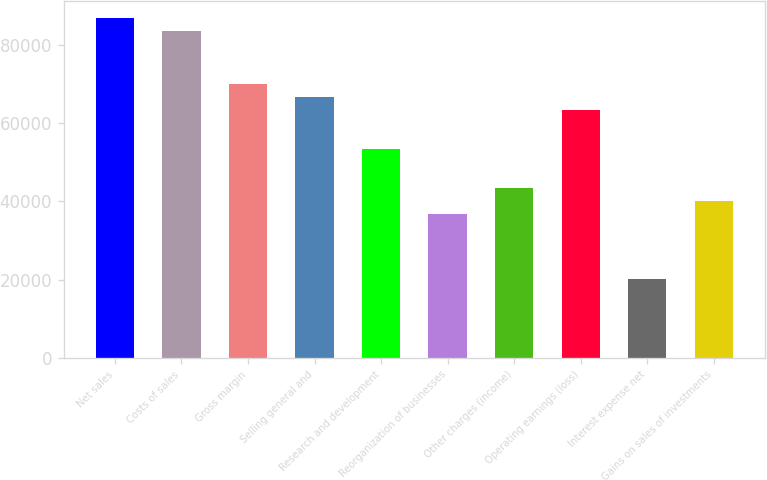Convert chart to OTSL. <chart><loc_0><loc_0><loc_500><loc_500><bar_chart><fcel>Net sales<fcel>Costs of sales<fcel>Gross margin<fcel>Selling general and<fcel>Research and development<fcel>Reorganization of businesses<fcel>Other charges (income)<fcel>Operating earnings (loss)<fcel>Interest expense net<fcel>Gains on sales of investments<nl><fcel>86834.4<fcel>83494.7<fcel>70135.5<fcel>66795.8<fcel>53436.6<fcel>36737.7<fcel>43417.3<fcel>63456<fcel>20038.8<fcel>40077.5<nl></chart> 